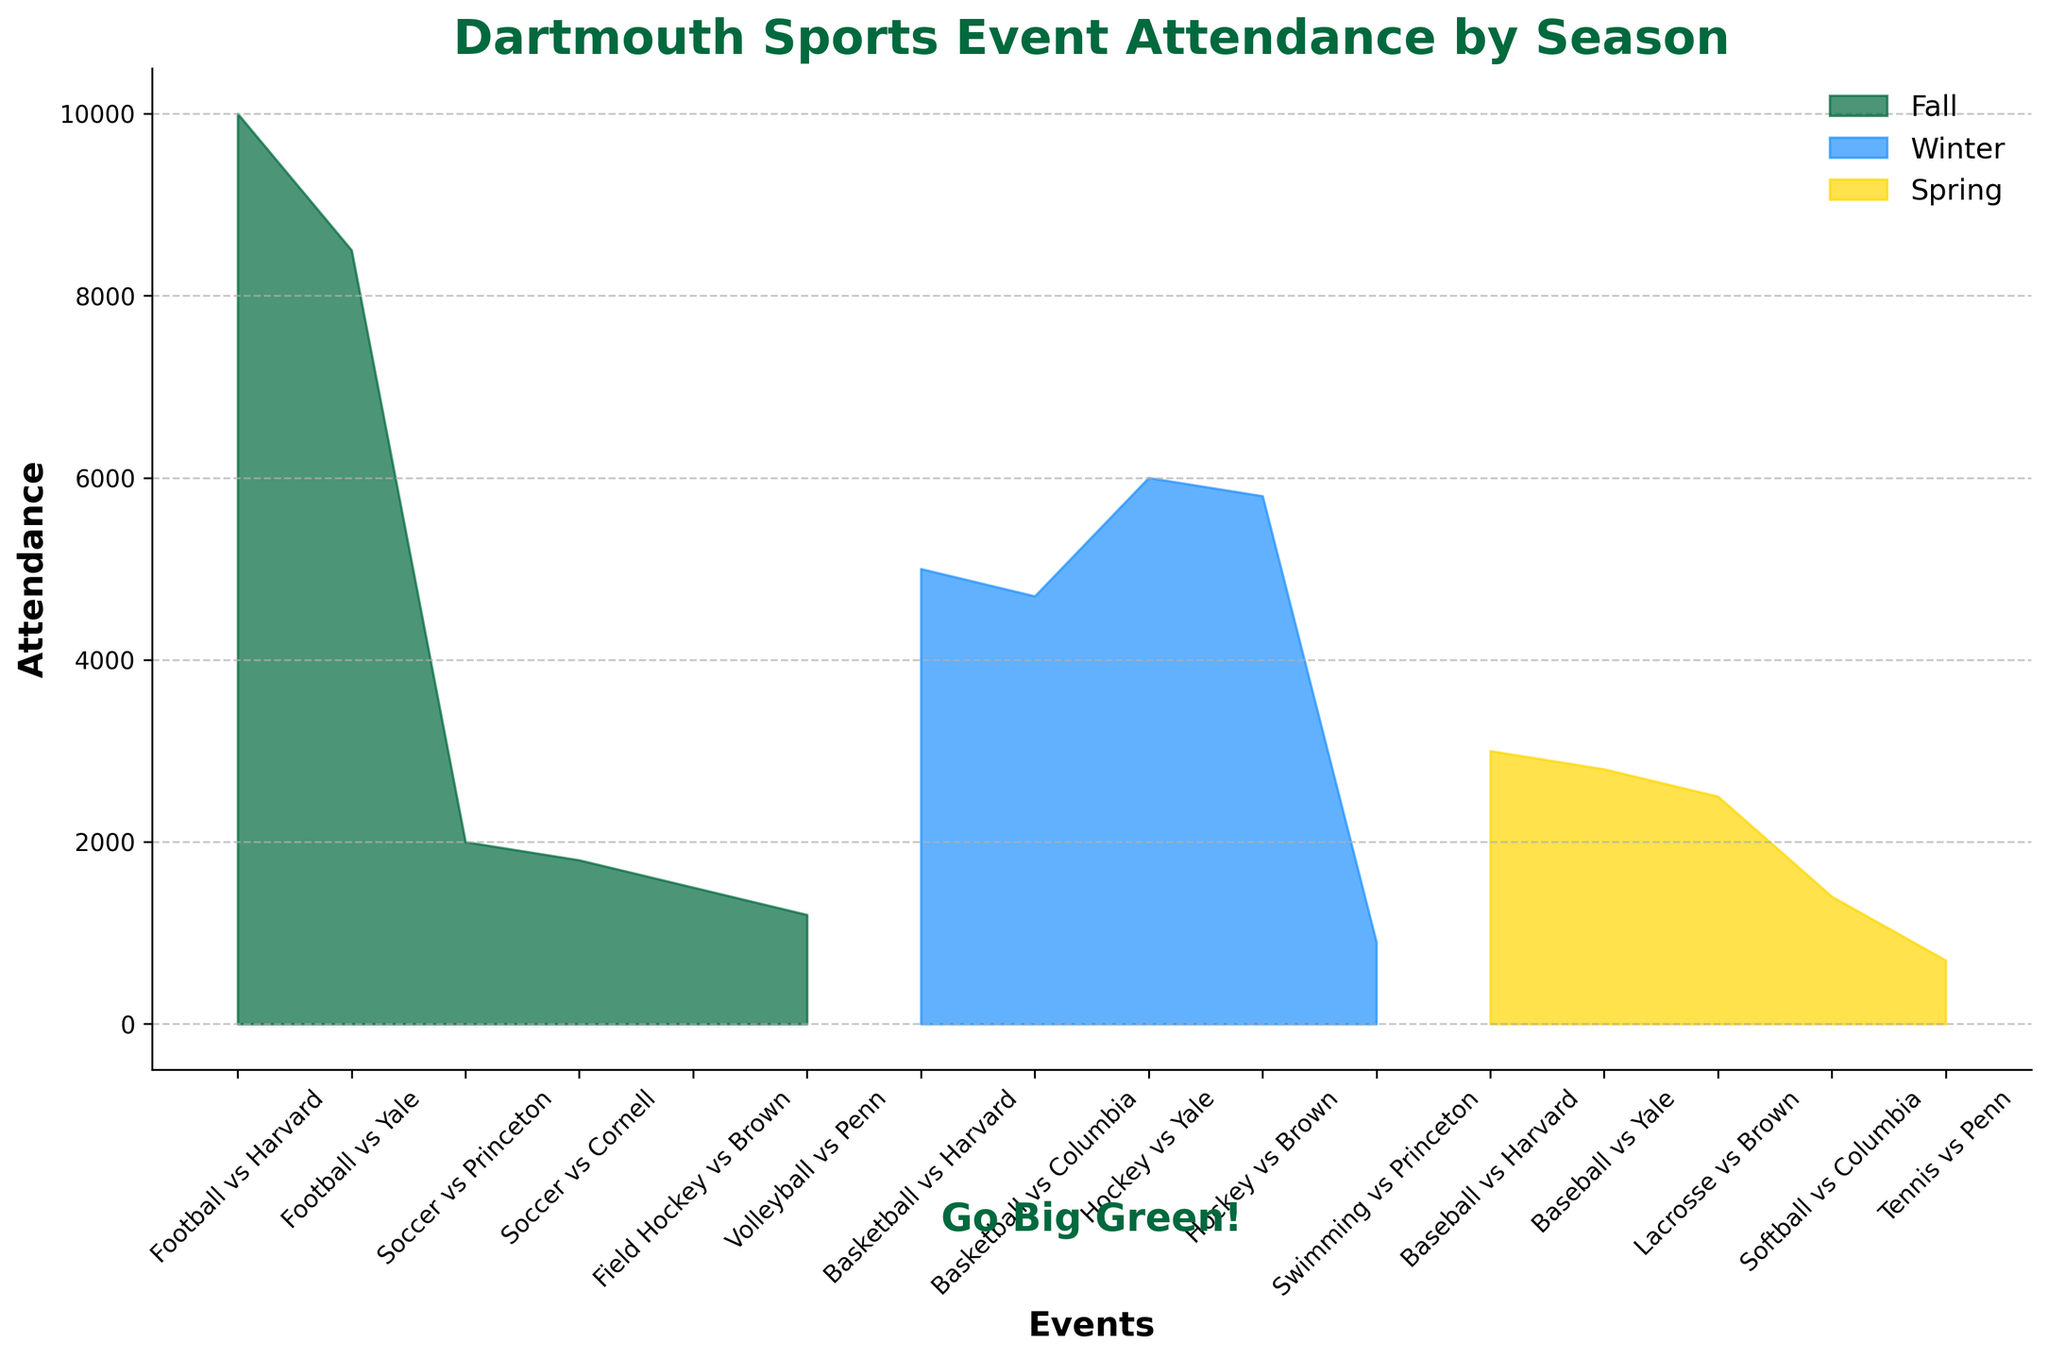What's the title of the figure? The title is located at the top of the figure in a bold and large font.
Answer: Dartmouth Sports Event Attendance by Season How many seasons are represented in the figure? The legend in the upper right corner lists three different colors, each representing a season.
Answer: 3 Which season has the event with the highest attendance? By observing the peaks in the area chart, the highest attendance for an event appears in the Fall season.
Answer: Fall What is the attendance difference between "Football vs Harvard" (Fall) and "Hockey vs Yale" (Winter)? The attendance for "Football vs Harvard" is 10,000 and for "Hockey vs Yale" is 6,000. The difference is 10,000 - 6,000.
Answer: 4,000 Which sport event has the lowest attendance, and in which season does it occur? The lowest attendance is represented by the smallest peak, which is “Tennis vs Penn” in the Spring season.
Answer: Tennis vs Penn (Spring) How does the attendance of "Basketball vs Harvard" (Winter) compare to "Softball vs Columbia" (Spring)? The heights of the peaks indicate attendance; "Basketball vs Harvard" has 5,000 attendees, and "Softball vs Columbia" has 1,400.
Answer: Basketball vs Harvard has higher attendance What’s the average attendance for all Football games in Fall season? The Football games in Fall are “Football vs Harvard” with 10,000 and “Football vs Yale” with 8,500. The average is (10,000 + 8,500) / 2.
Answer: 9,250 Compare the total attendance of all events in Winter versus Spring. Sum the attendance values for Winter and for Spring, then compare: Winter (5,000 + 4,700 + 6,000 + 5,800 + 900) and Spring (3,000 + 2,800 + 2,500 + 1,400 + 700).
Answer: Winter has higher total attendance Is the attendance for "Soccer vs Princeton" higher than "Baseball vs Harvard"? Compare the heights of the peaks for these events; "Soccer vs Princeton" is 2,000 and "Baseball vs Harvard" is 3,000.
Answer: No Which season has the most events with attendance above 5,000? Count the number of peaks above 5,000 in each season: Fall (0), Winter (2), Spring (0).
Answer: Winter 